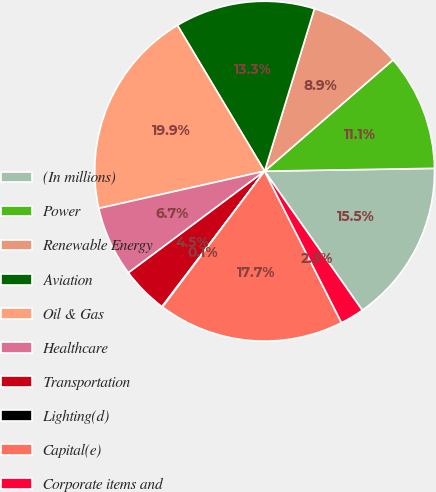Convert chart. <chart><loc_0><loc_0><loc_500><loc_500><pie_chart><fcel>(In millions)<fcel>Power<fcel>Renewable Energy<fcel>Aviation<fcel>Oil & Gas<fcel>Healthcare<fcel>Transportation<fcel>Lighting(d)<fcel>Capital(e)<fcel>Corporate items and<nl><fcel>15.52%<fcel>11.1%<fcel>8.9%<fcel>13.31%<fcel>19.94%<fcel>6.69%<fcel>4.48%<fcel>0.06%<fcel>17.73%<fcel>2.27%<nl></chart> 